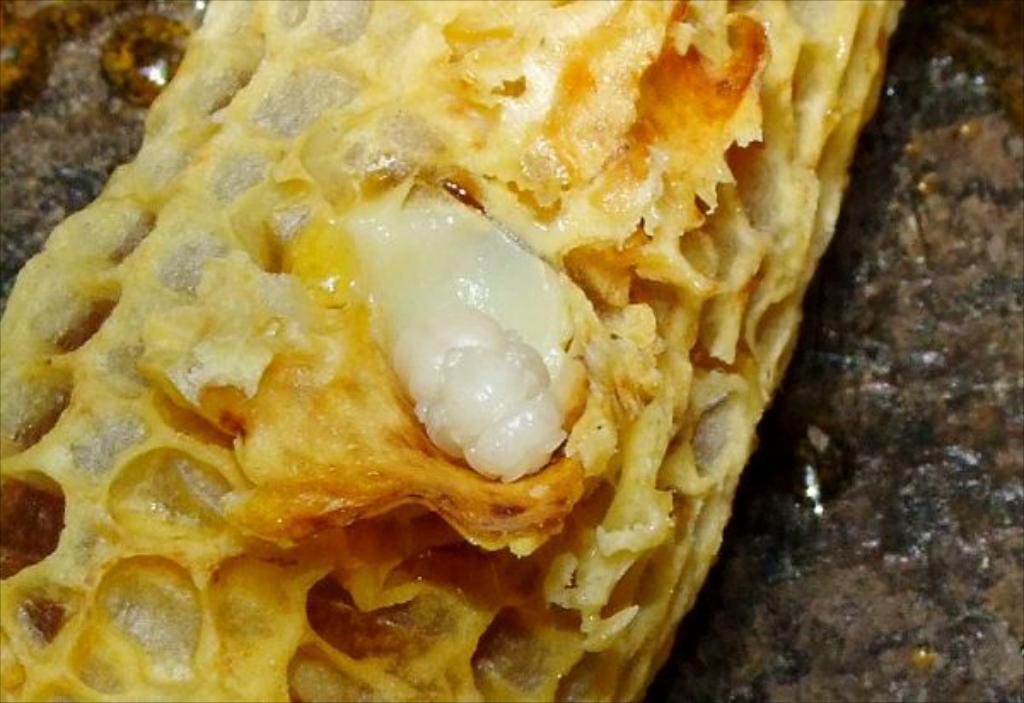How would you summarize this image in a sentence or two? In this image we can see a food item. 